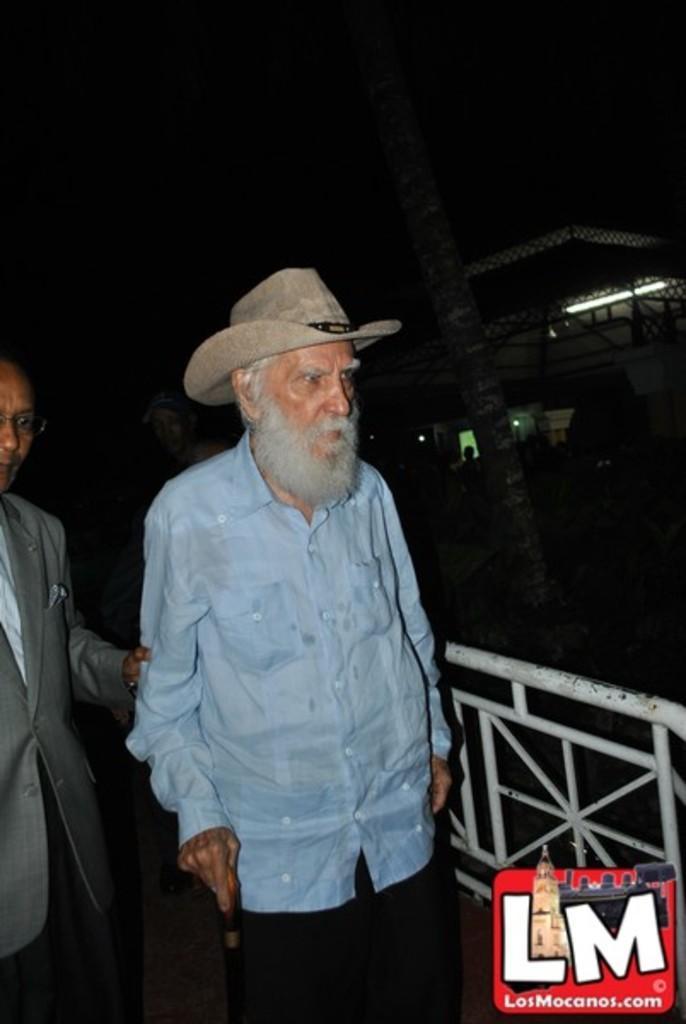Describe this image in one or two sentences. As we can see in the image in the front there are two persons. In the background there is building and light. The image is little dark. 